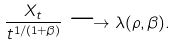<formula> <loc_0><loc_0><loc_500><loc_500>\frac { X _ { t } } { t ^ { 1 / ( 1 + \beta ) } } \longrightarrow \lambda ( \rho , \beta ) .</formula> 